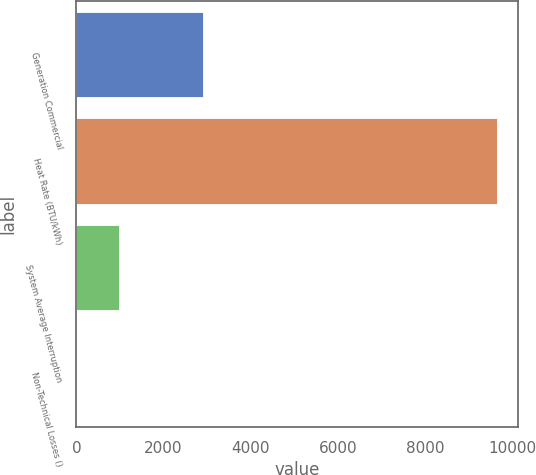<chart> <loc_0><loc_0><loc_500><loc_500><bar_chart><fcel>Generation Commercial<fcel>Heat Rate (BTU/kWh)<fcel>System Average Interruption<fcel>Non-Technical Losses ()<nl><fcel>2893.17<fcel>9638<fcel>966.07<fcel>2.52<nl></chart> 